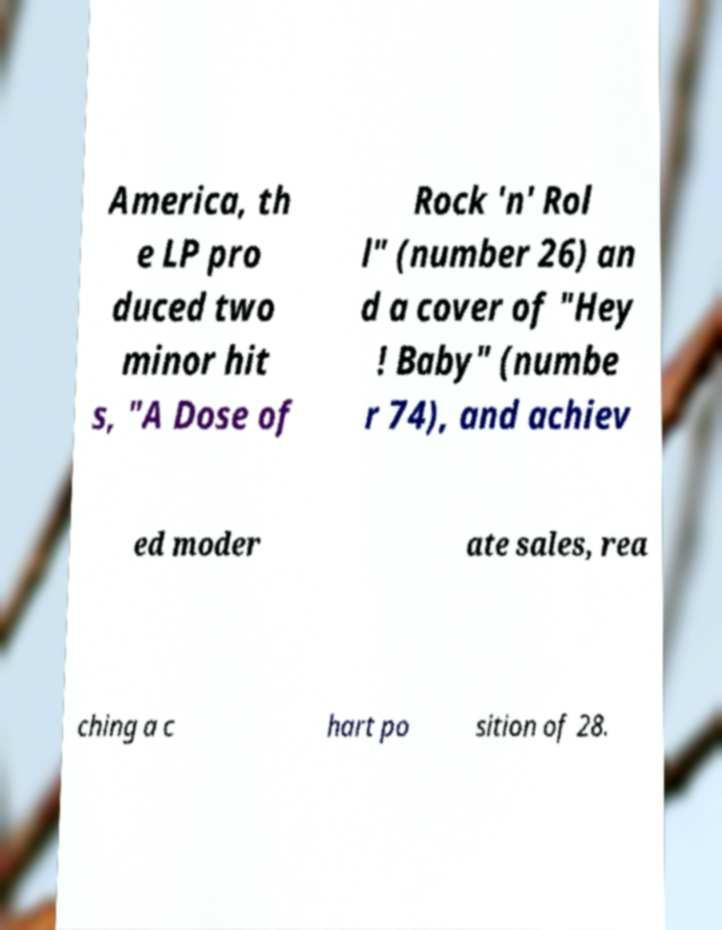Can you accurately transcribe the text from the provided image for me? America, th e LP pro duced two minor hit s, "A Dose of Rock 'n' Rol l" (number 26) an d a cover of "Hey ! Baby" (numbe r 74), and achiev ed moder ate sales, rea ching a c hart po sition of 28. 